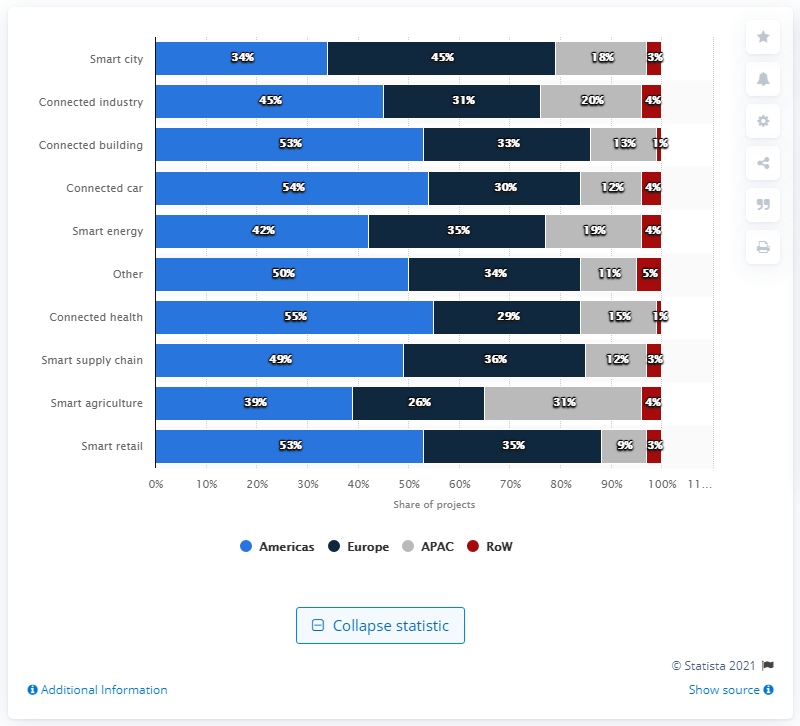Draw attention to some important aspects in this diagram. The dark blue bar indicates that if two categories are added together, the result would be 63%. If one of the categories is 'connected car', then the other category must be 'connected building'. 